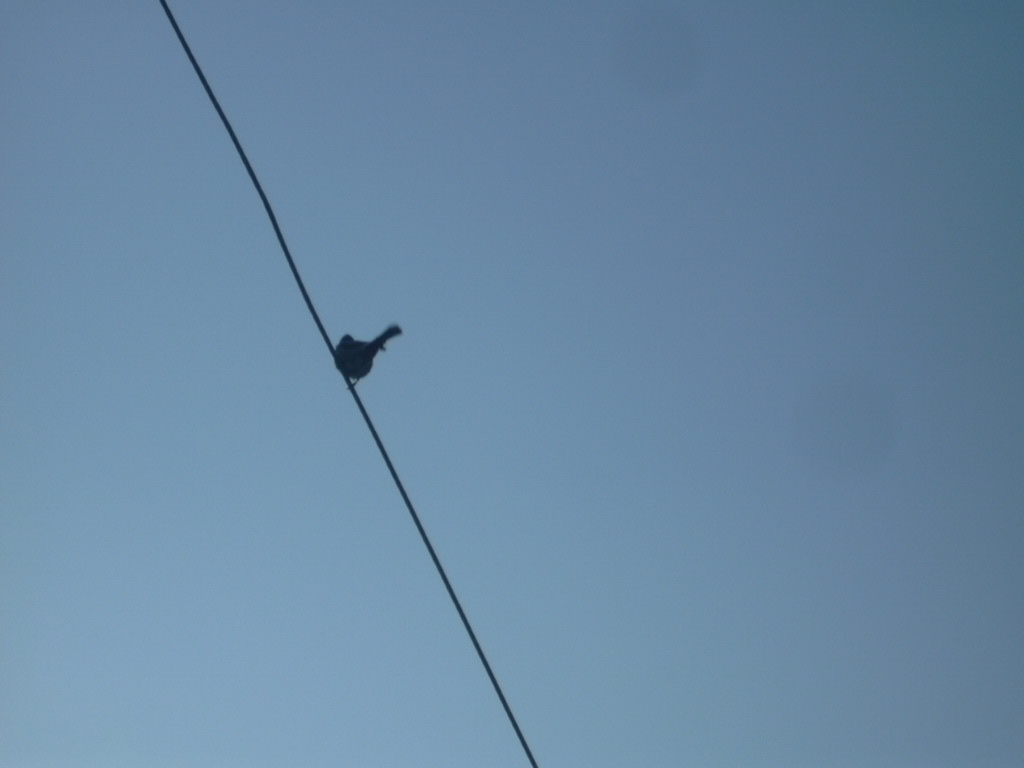How might the feeling of this photo change if there were multiple birds on the wire? With multiple birds, the image might convey a sense of community or interaction among the birds, and could give the image a more dynamic or lively feel as opposed to the solitary and tranquil vibe it currently has. 